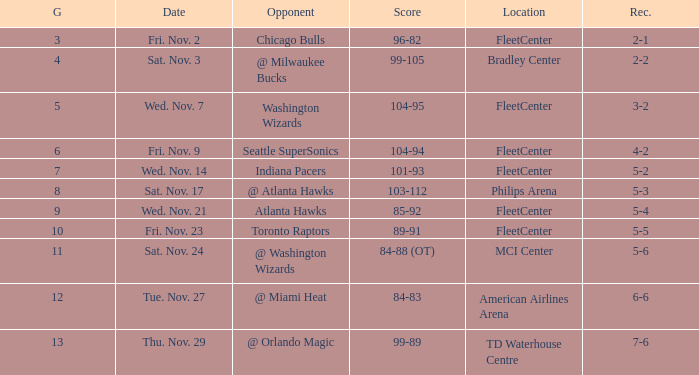How many games have a score of 85-92? 1.0. 